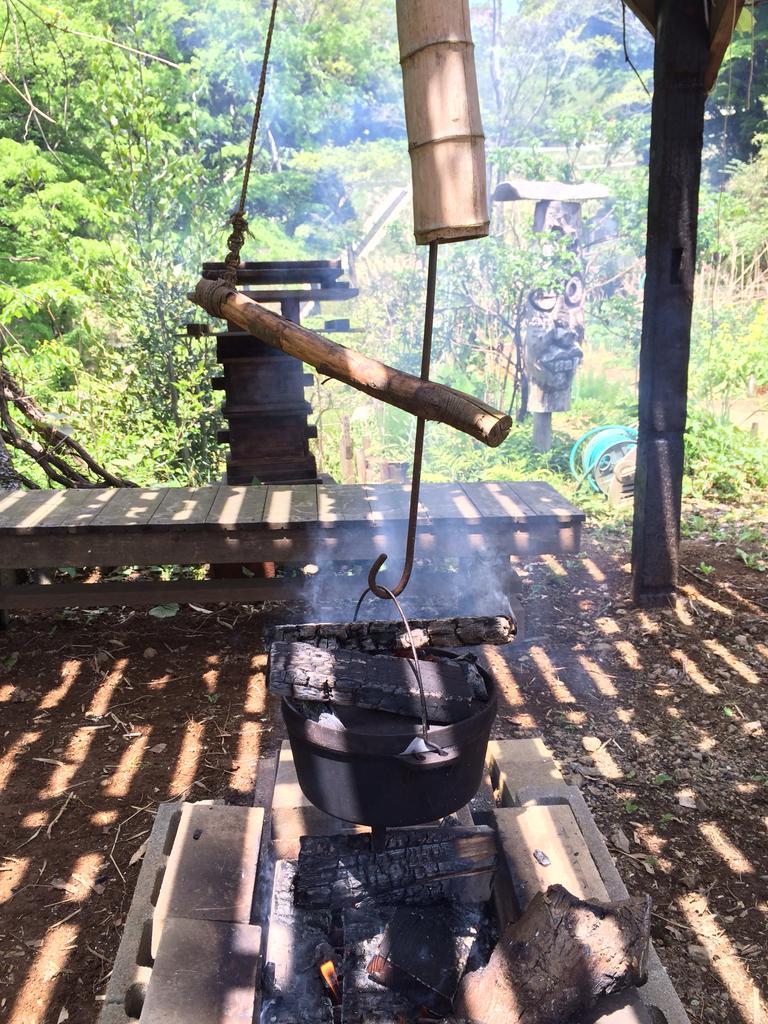Please provide a concise description of this image. In this image there are a few wooden logs in a bucket, beneath the bucket there is fire generated from wood, in front of the bucket there is a wooden bench, in the background of the image there are trees. 